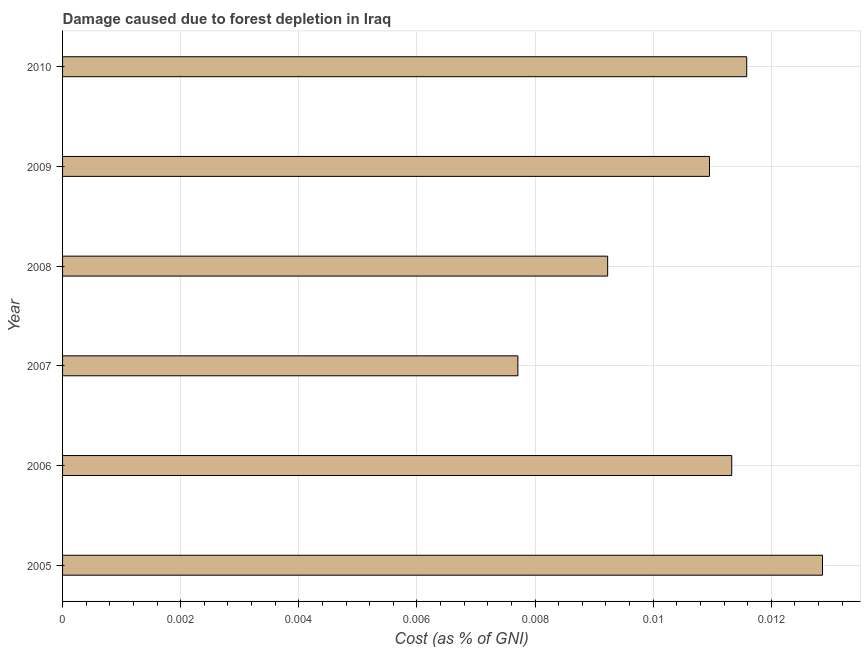What is the title of the graph?
Make the answer very short. Damage caused due to forest depletion in Iraq. What is the label or title of the X-axis?
Ensure brevity in your answer.  Cost (as % of GNI). What is the label or title of the Y-axis?
Keep it short and to the point. Year. What is the damage caused due to forest depletion in 2009?
Offer a terse response. 0.01. Across all years, what is the maximum damage caused due to forest depletion?
Your answer should be compact. 0.01. Across all years, what is the minimum damage caused due to forest depletion?
Provide a short and direct response. 0.01. What is the sum of the damage caused due to forest depletion?
Your response must be concise. 0.06. What is the difference between the damage caused due to forest depletion in 2008 and 2009?
Provide a succinct answer. -0. What is the average damage caused due to forest depletion per year?
Your answer should be compact. 0.01. What is the median damage caused due to forest depletion?
Offer a terse response. 0.01. What is the ratio of the damage caused due to forest depletion in 2006 to that in 2008?
Provide a succinct answer. 1.23. Is the damage caused due to forest depletion in 2006 less than that in 2010?
Offer a terse response. Yes. What is the difference between the highest and the lowest damage caused due to forest depletion?
Provide a succinct answer. 0.01. What is the difference between two consecutive major ticks on the X-axis?
Make the answer very short. 0. What is the Cost (as % of GNI) in 2005?
Your response must be concise. 0.01. What is the Cost (as % of GNI) of 2006?
Offer a very short reply. 0.01. What is the Cost (as % of GNI) of 2007?
Offer a terse response. 0.01. What is the Cost (as % of GNI) in 2008?
Offer a very short reply. 0.01. What is the Cost (as % of GNI) of 2009?
Your response must be concise. 0.01. What is the Cost (as % of GNI) in 2010?
Give a very brief answer. 0.01. What is the difference between the Cost (as % of GNI) in 2005 and 2006?
Keep it short and to the point. 0. What is the difference between the Cost (as % of GNI) in 2005 and 2007?
Ensure brevity in your answer.  0.01. What is the difference between the Cost (as % of GNI) in 2005 and 2008?
Provide a short and direct response. 0. What is the difference between the Cost (as % of GNI) in 2005 and 2009?
Your answer should be compact. 0. What is the difference between the Cost (as % of GNI) in 2005 and 2010?
Your response must be concise. 0. What is the difference between the Cost (as % of GNI) in 2006 and 2007?
Provide a succinct answer. 0. What is the difference between the Cost (as % of GNI) in 2006 and 2008?
Ensure brevity in your answer.  0. What is the difference between the Cost (as % of GNI) in 2006 and 2009?
Ensure brevity in your answer.  0. What is the difference between the Cost (as % of GNI) in 2006 and 2010?
Your answer should be compact. -0. What is the difference between the Cost (as % of GNI) in 2007 and 2008?
Keep it short and to the point. -0. What is the difference between the Cost (as % of GNI) in 2007 and 2009?
Ensure brevity in your answer.  -0. What is the difference between the Cost (as % of GNI) in 2007 and 2010?
Provide a short and direct response. -0. What is the difference between the Cost (as % of GNI) in 2008 and 2009?
Ensure brevity in your answer.  -0. What is the difference between the Cost (as % of GNI) in 2008 and 2010?
Offer a terse response. -0. What is the difference between the Cost (as % of GNI) in 2009 and 2010?
Your answer should be compact. -0. What is the ratio of the Cost (as % of GNI) in 2005 to that in 2006?
Offer a terse response. 1.14. What is the ratio of the Cost (as % of GNI) in 2005 to that in 2007?
Offer a terse response. 1.67. What is the ratio of the Cost (as % of GNI) in 2005 to that in 2008?
Ensure brevity in your answer.  1.39. What is the ratio of the Cost (as % of GNI) in 2005 to that in 2009?
Your response must be concise. 1.18. What is the ratio of the Cost (as % of GNI) in 2005 to that in 2010?
Make the answer very short. 1.11. What is the ratio of the Cost (as % of GNI) in 2006 to that in 2007?
Provide a succinct answer. 1.47. What is the ratio of the Cost (as % of GNI) in 2006 to that in 2008?
Provide a succinct answer. 1.23. What is the ratio of the Cost (as % of GNI) in 2006 to that in 2009?
Give a very brief answer. 1.03. What is the ratio of the Cost (as % of GNI) in 2007 to that in 2008?
Offer a very short reply. 0.83. What is the ratio of the Cost (as % of GNI) in 2007 to that in 2009?
Give a very brief answer. 0.7. What is the ratio of the Cost (as % of GNI) in 2007 to that in 2010?
Provide a succinct answer. 0.67. What is the ratio of the Cost (as % of GNI) in 2008 to that in 2009?
Provide a short and direct response. 0.84. What is the ratio of the Cost (as % of GNI) in 2008 to that in 2010?
Your answer should be very brief. 0.8. What is the ratio of the Cost (as % of GNI) in 2009 to that in 2010?
Your answer should be very brief. 0.95. 